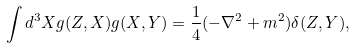<formula> <loc_0><loc_0><loc_500><loc_500>\int d ^ { 3 } X g ( Z , X ) g ( X , Y ) = \frac { 1 } { 4 } ( - \nabla ^ { 2 } + m ^ { 2 } ) \delta ( Z , Y ) ,</formula> 